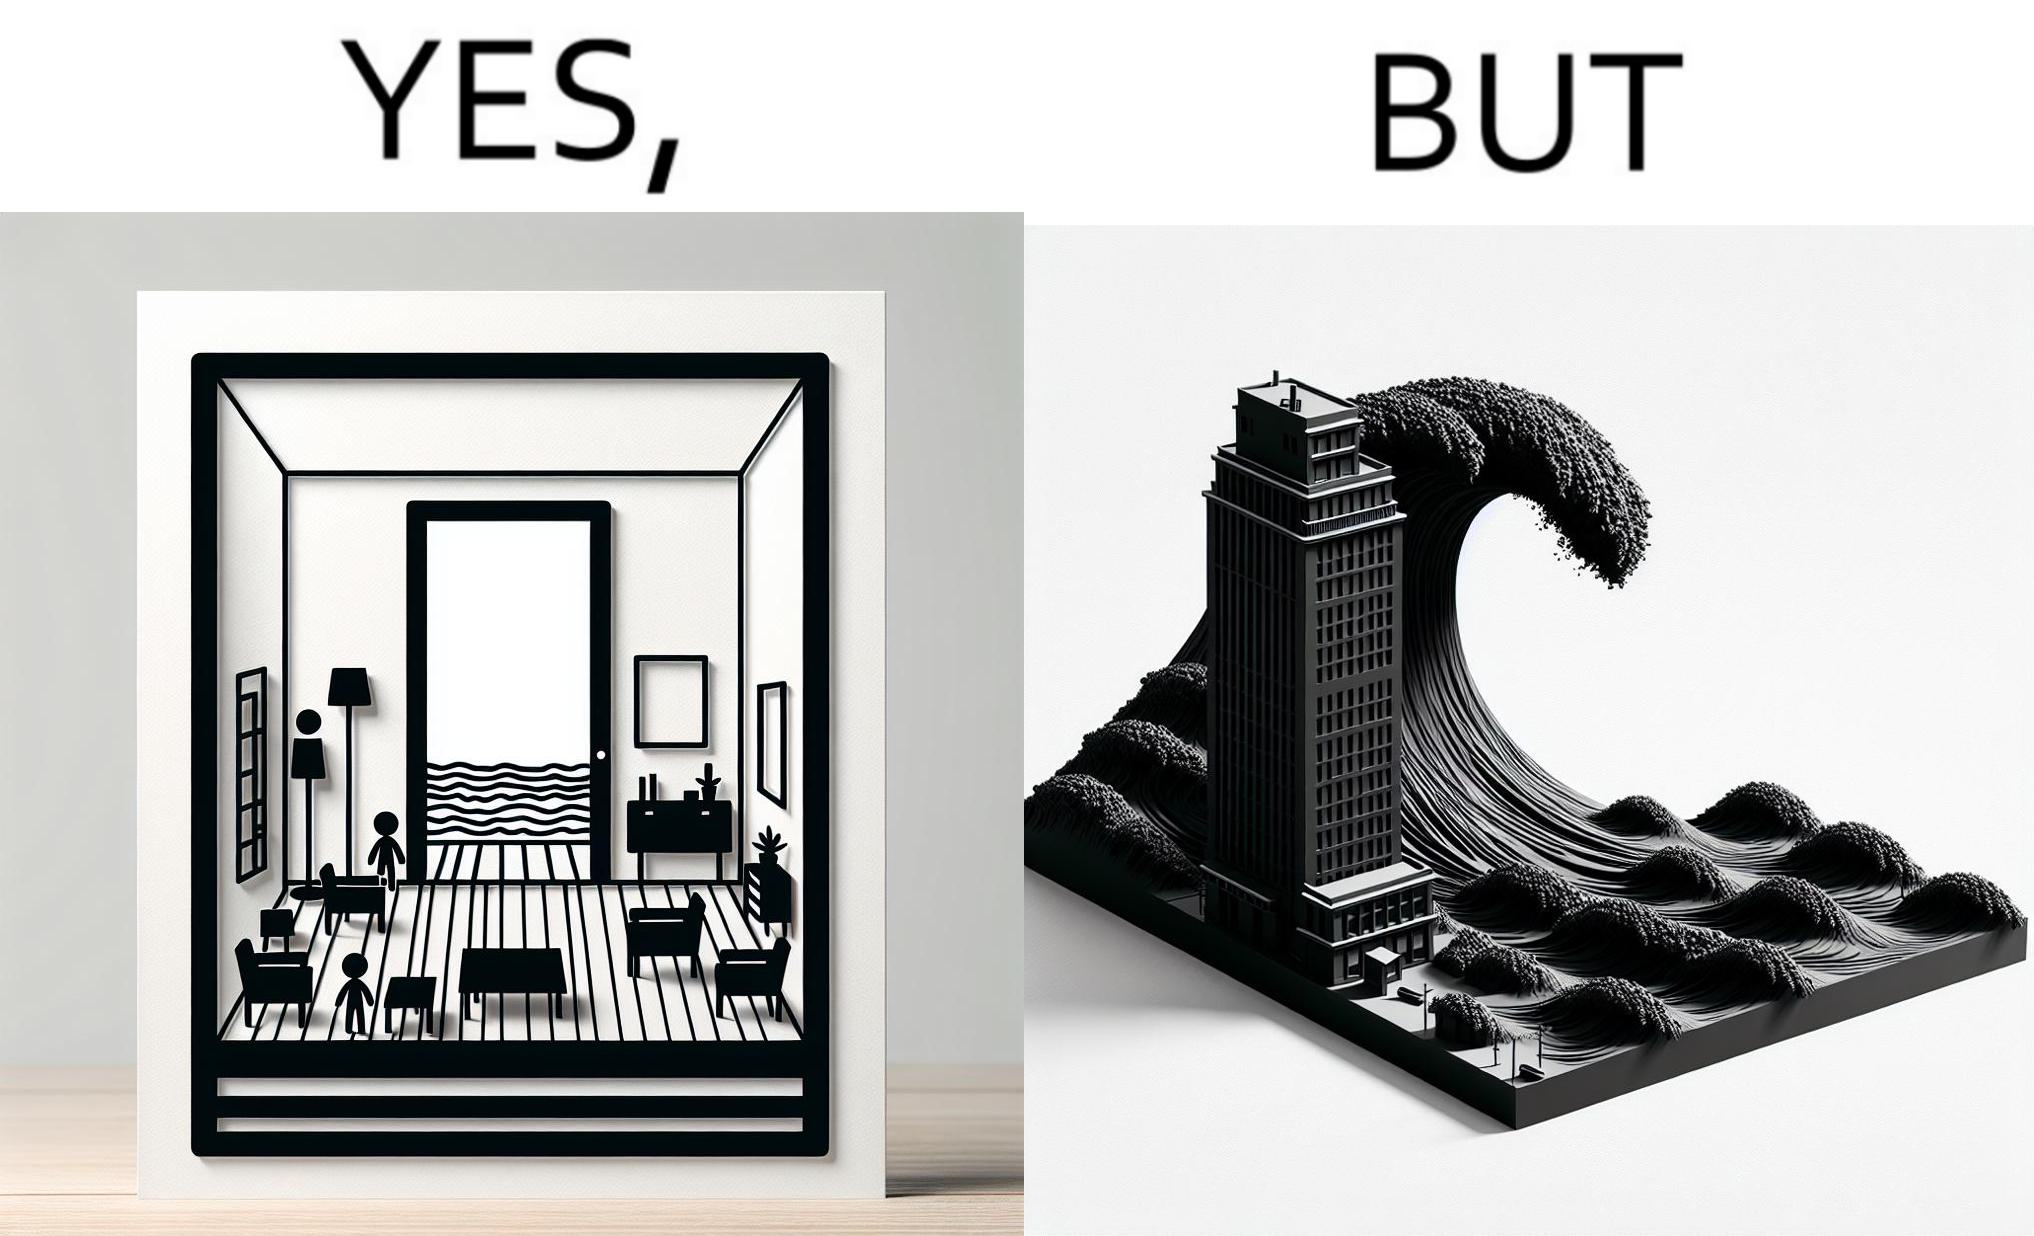Describe the contrast between the left and right parts of this image. In the left part of the image: a room with a sea-facing door In the right part of the image: high waves in the sea twice of the height of the building near the sea 